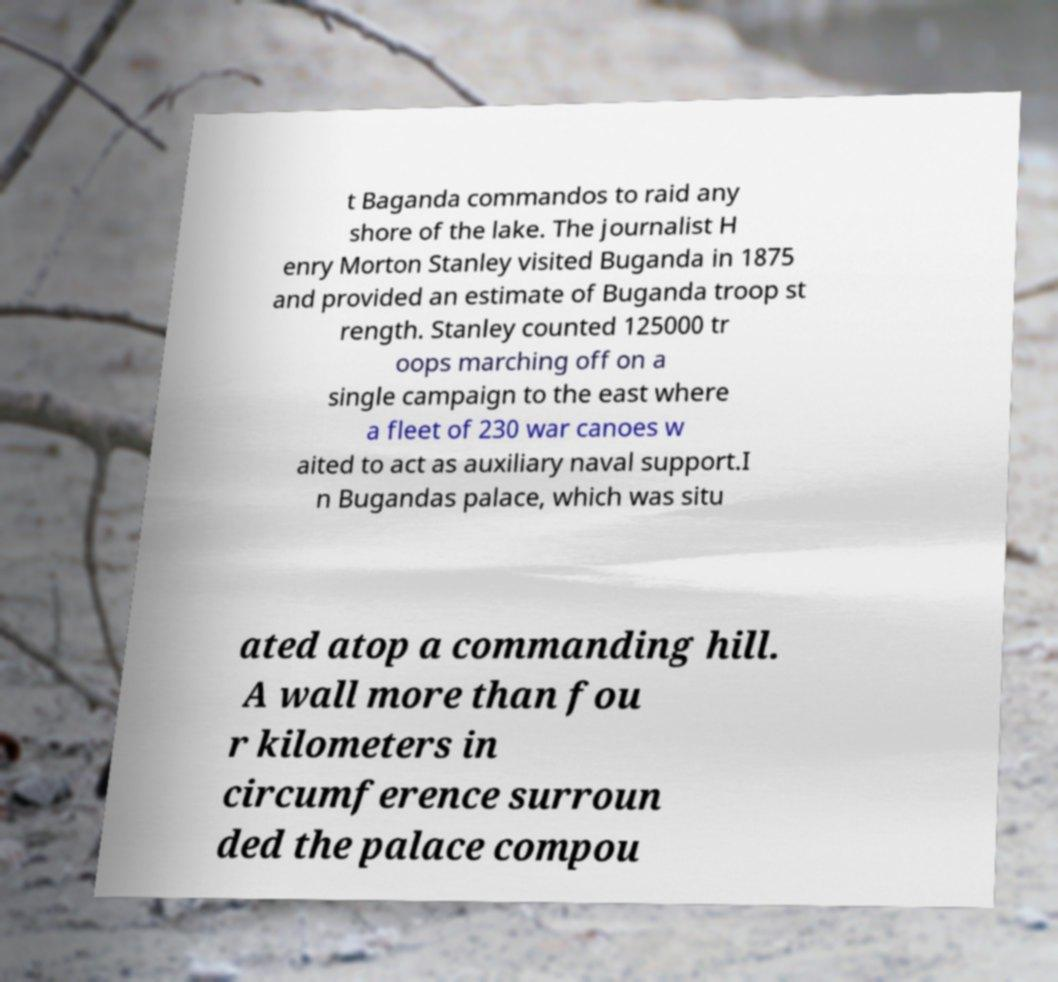What messages or text are displayed in this image? I need them in a readable, typed format. t Baganda commandos to raid any shore of the lake. The journalist H enry Morton Stanley visited Buganda in 1875 and provided an estimate of Buganda troop st rength. Stanley counted 125000 tr oops marching off on a single campaign to the east where a fleet of 230 war canoes w aited to act as auxiliary naval support.I n Bugandas palace, which was situ ated atop a commanding hill. A wall more than fou r kilometers in circumference surroun ded the palace compou 